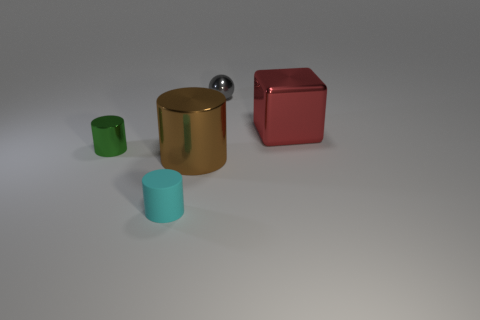Add 4 purple matte balls. How many objects exist? 9 Subtract all brown cylinders. How many cylinders are left? 2 Subtract all cylinders. How many objects are left? 2 Subtract all brown cylinders. How many cylinders are left? 2 Subtract 1 spheres. How many spheres are left? 0 Subtract all red balls. Subtract all blue blocks. How many balls are left? 1 Subtract all big objects. Subtract all small cyan metal objects. How many objects are left? 3 Add 5 small cyan matte things. How many small cyan matte things are left? 6 Add 5 cyan objects. How many cyan objects exist? 6 Subtract 1 gray balls. How many objects are left? 4 